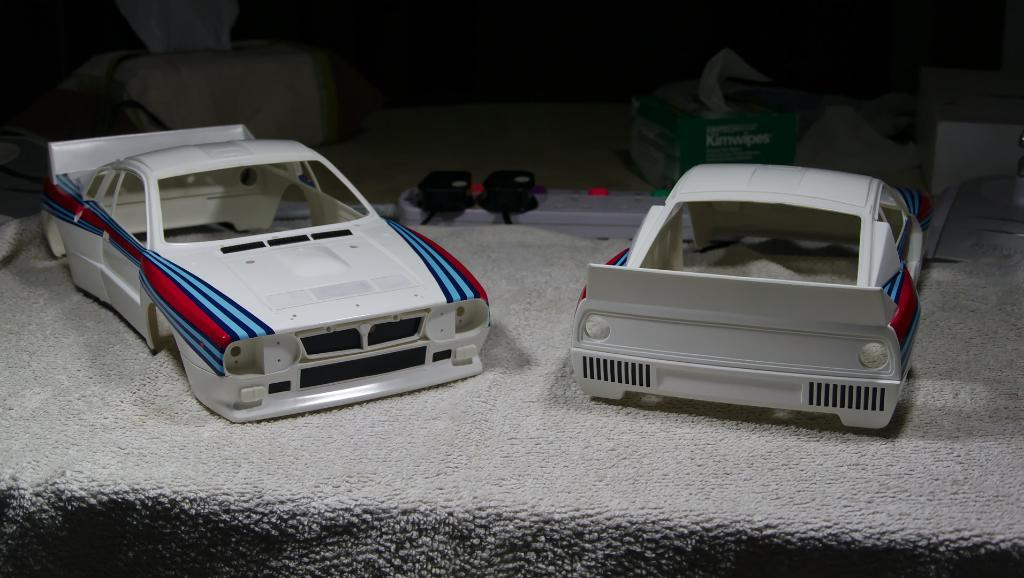What objects can be seen in the image? There are toys and a tissue box in the image. Can you describe the toys in the image? The toys in the image are not specified, but they are present. What is the purpose of the tissue box in the image? The purpose of the tissue box in the image is to hold tissues. What type of leather is used to make the lunch in the image? There is no lunch present in the image, and therefore no leather can be associated with it. 